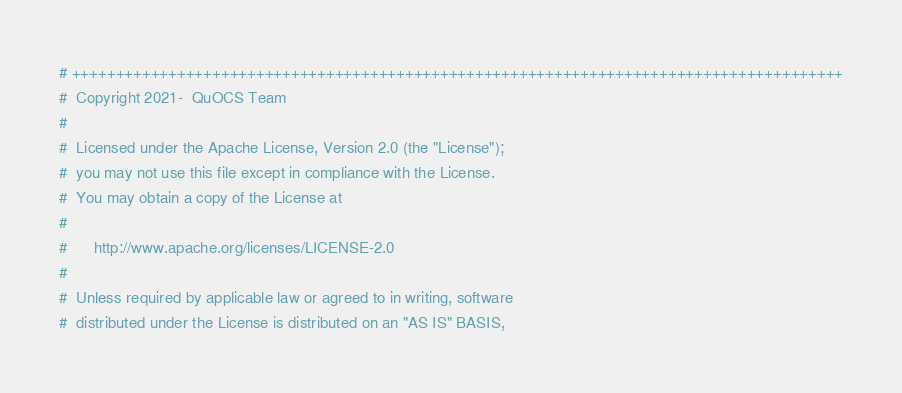<code> <loc_0><loc_0><loc_500><loc_500><_Python_># ++++++++++++++++++++++++++++++++++++++++++++++++++++++++++++++++++++++++++++++++++++++++
#  Copyright 2021-  QuOCS Team
#
#  Licensed under the Apache License, Version 2.0 (the "License");
#  you may not use this file except in compliance with the License.
#  You may obtain a copy of the License at
#
#      http://www.apache.org/licenses/LICENSE-2.0
#
#  Unless required by applicable law or agreed to in writing, software
#  distributed under the License is distributed on an "AS IS" BASIS,</code> 